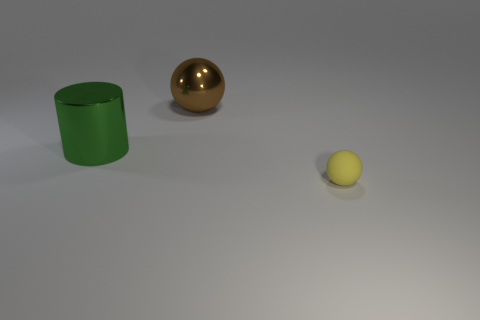Add 3 balls. How many objects exist? 6 Subtract all spheres. How many objects are left? 1 Add 1 brown spheres. How many brown spheres are left? 2 Add 2 tiny gray matte blocks. How many tiny gray matte blocks exist? 2 Subtract 0 red cylinders. How many objects are left? 3 Subtract all gray rubber cylinders. Subtract all big green shiny cylinders. How many objects are left? 2 